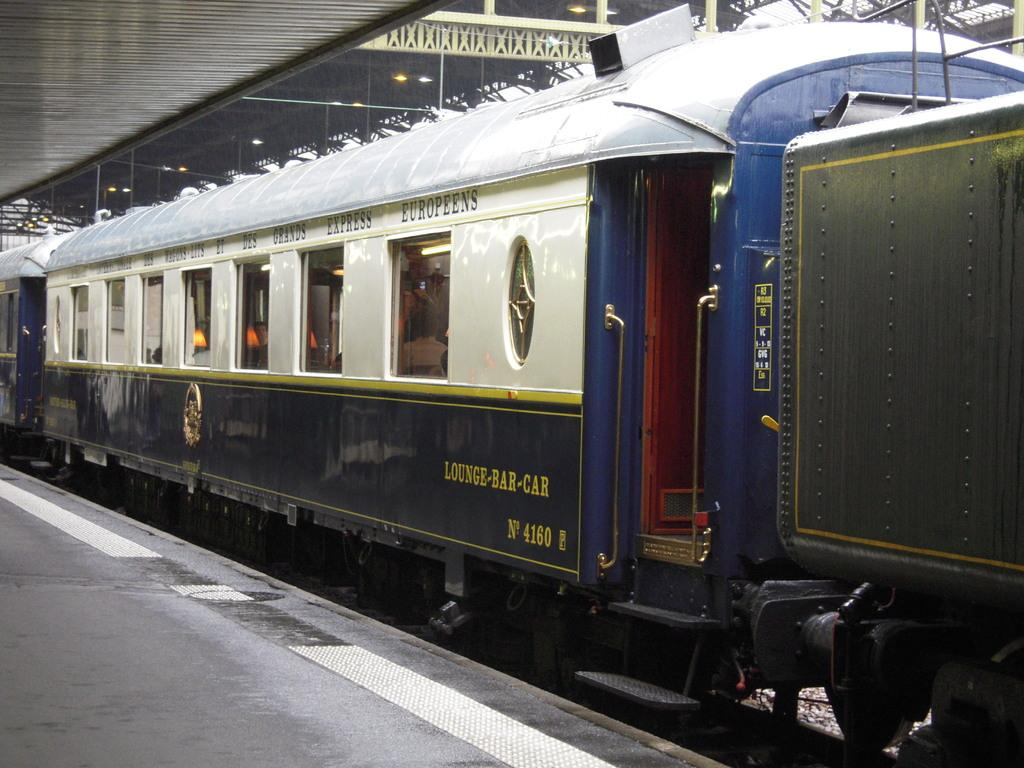<image>
Render a clear and concise summary of the photo. The train car has words on the side that indicate it's the lounge bar car. 